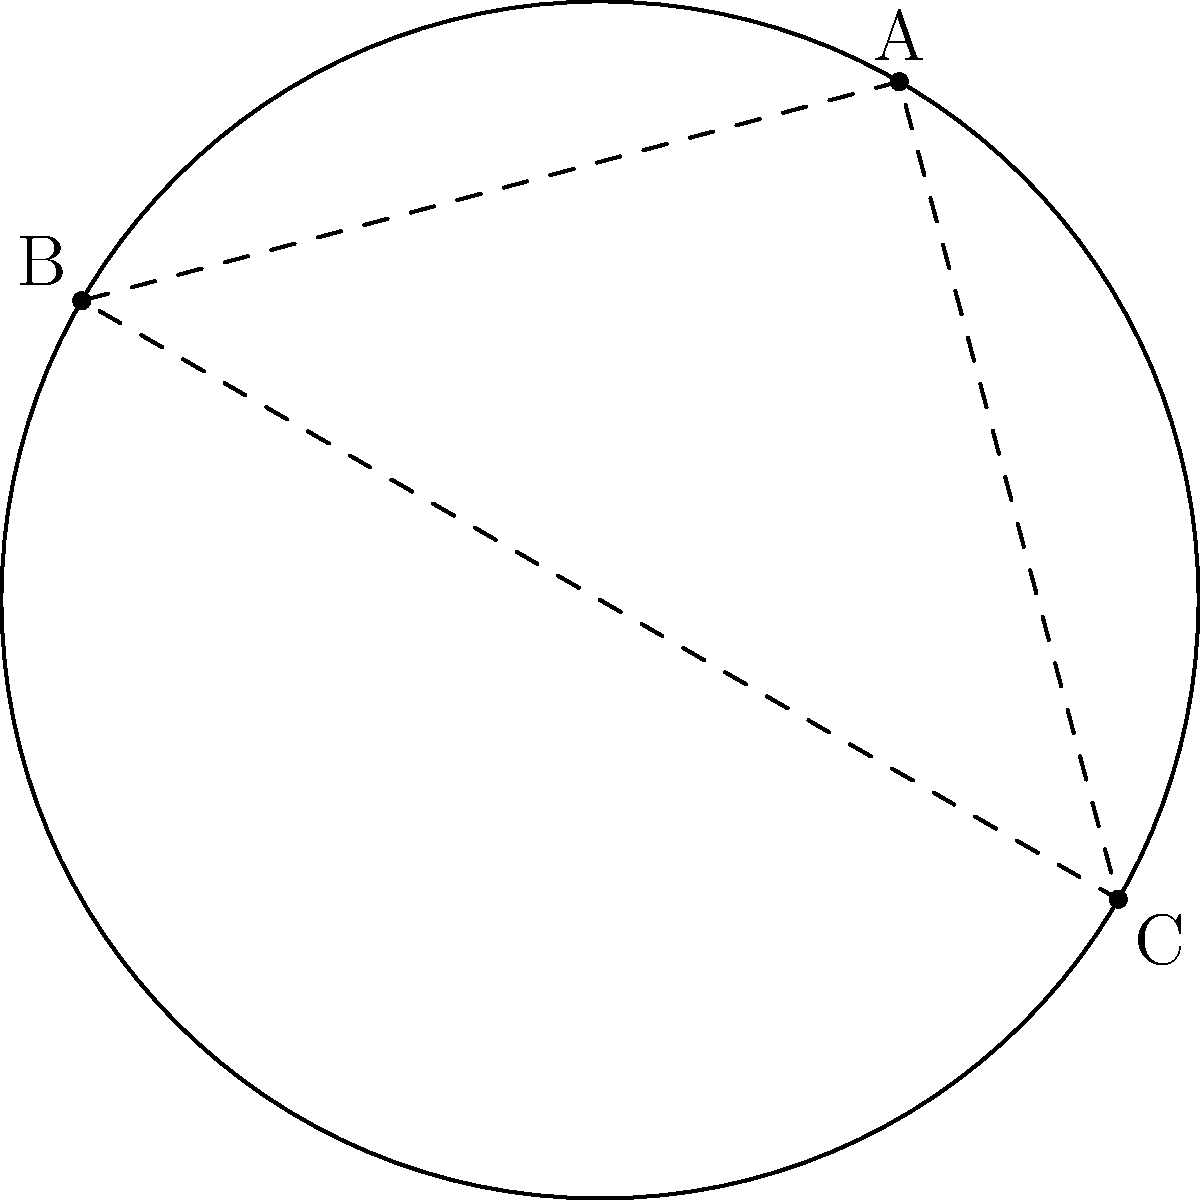A circular blood spatter pattern was found at a crime scene. Three points on the circumference of the pattern were identified: A(1.5, 2.598), B(-2.598, 1.5), and C(2.598, -1.5). Determine the center coordinates and radius of the circular pattern. To find the center and radius of the circular blood spatter pattern, we'll follow these steps:

1) The center of the circle is equidistant from all points on the circumference. We can use the perpendicular bisector method to find it.

2) Find the midpoint of two chords:
   AB midpoint: $M_1 = (\frac{1.5 + (-2.598)}{2}, \frac{2.598 + 1.5}{2}) = (-0.549, 2.049)$
   BC midpoint: $M_2 = (\frac{-2.598 + 2.598}{2}, \frac{1.5 + (-1.5)}{2}) = (0, 0)$

3) Calculate the slopes of AB and BC:
   $m_{AB} = \frac{2.598 - 1.5}{1.5 - (-2.598)} = \frac{1.098}{4.098} \approx 0.268$
   $m_{BC} = \frac{-1.5 - 1.5}{2.598 - (-2.598)} = \frac{-3}{5.196} \approx -0.577$

4) The perpendicular bisectors have slopes that are negative reciprocals of these:
   $m_1 = -\frac{1}{m_{AB}} \approx -3.732$
   $m_2 = -\frac{1}{m_{BC}} \approx 1.732$

5) Use point-slope form to write equations for the perpendicular bisectors:
   $y - 2.049 = -3.732(x + 0.549)$
   $y - 0 = 1.732x$

6) Solve these equations simultaneously to find their intersection (the center):
   $x = 0$, $y = 0$

7) To find the radius, calculate the distance from the center to any point on the circumference:
   $r = \sqrt{(1.5 - 0)^2 + (2.598 - 0)^2} = 3$

Therefore, the center is at (0, 0) and the radius is 3 units.
Answer: Center: (0, 0); Radius: 3 